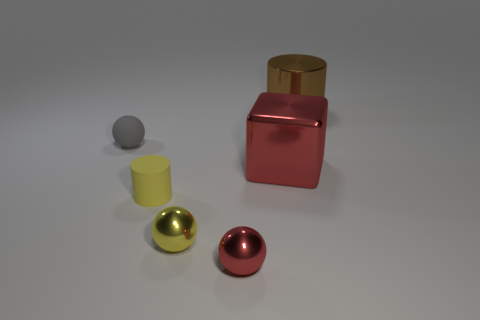Subtract all tiny yellow metallic balls. How many balls are left? 2 Add 4 small purple matte cubes. How many objects exist? 10 Subtract all brown cylinders. How many cylinders are left? 1 Subtract all cylinders. How many objects are left? 4 Subtract all red blocks. How many gray balls are left? 1 Subtract all large metal cylinders. Subtract all big metallic things. How many objects are left? 3 Add 1 tiny yellow objects. How many tiny yellow objects are left? 3 Add 2 red shiny spheres. How many red shiny spheres exist? 3 Subtract 0 purple blocks. How many objects are left? 6 Subtract all gray cubes. Subtract all gray balls. How many cubes are left? 1 